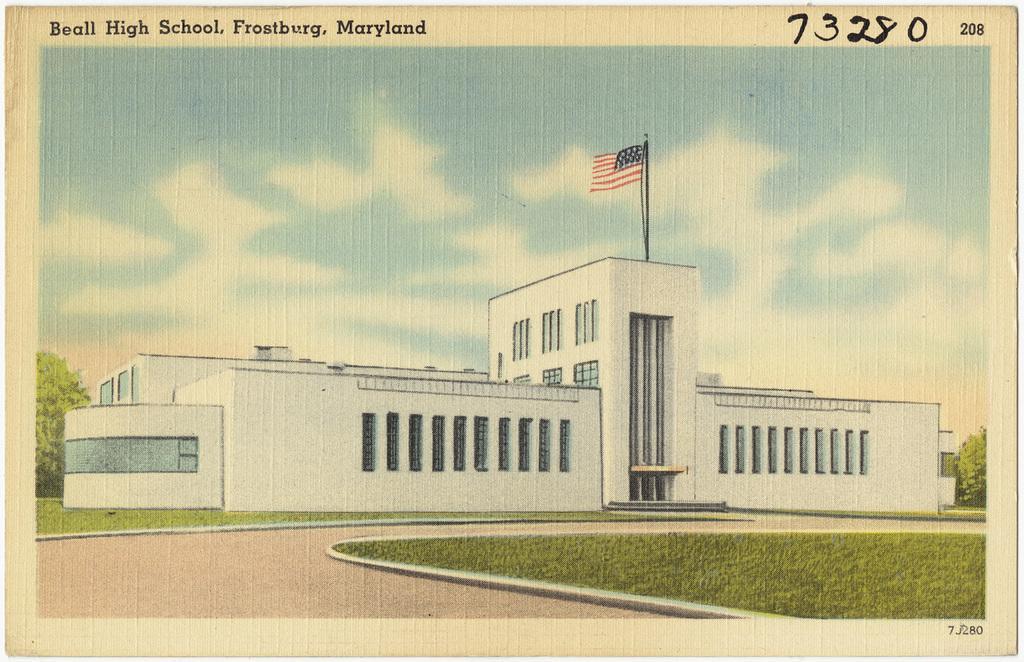How would you summarize this image in a sentence or two? In this picture I can see there is a picture and there is a building in the picture and there is a flag on the top of the building and the sky is clear and there is something written on the image. 